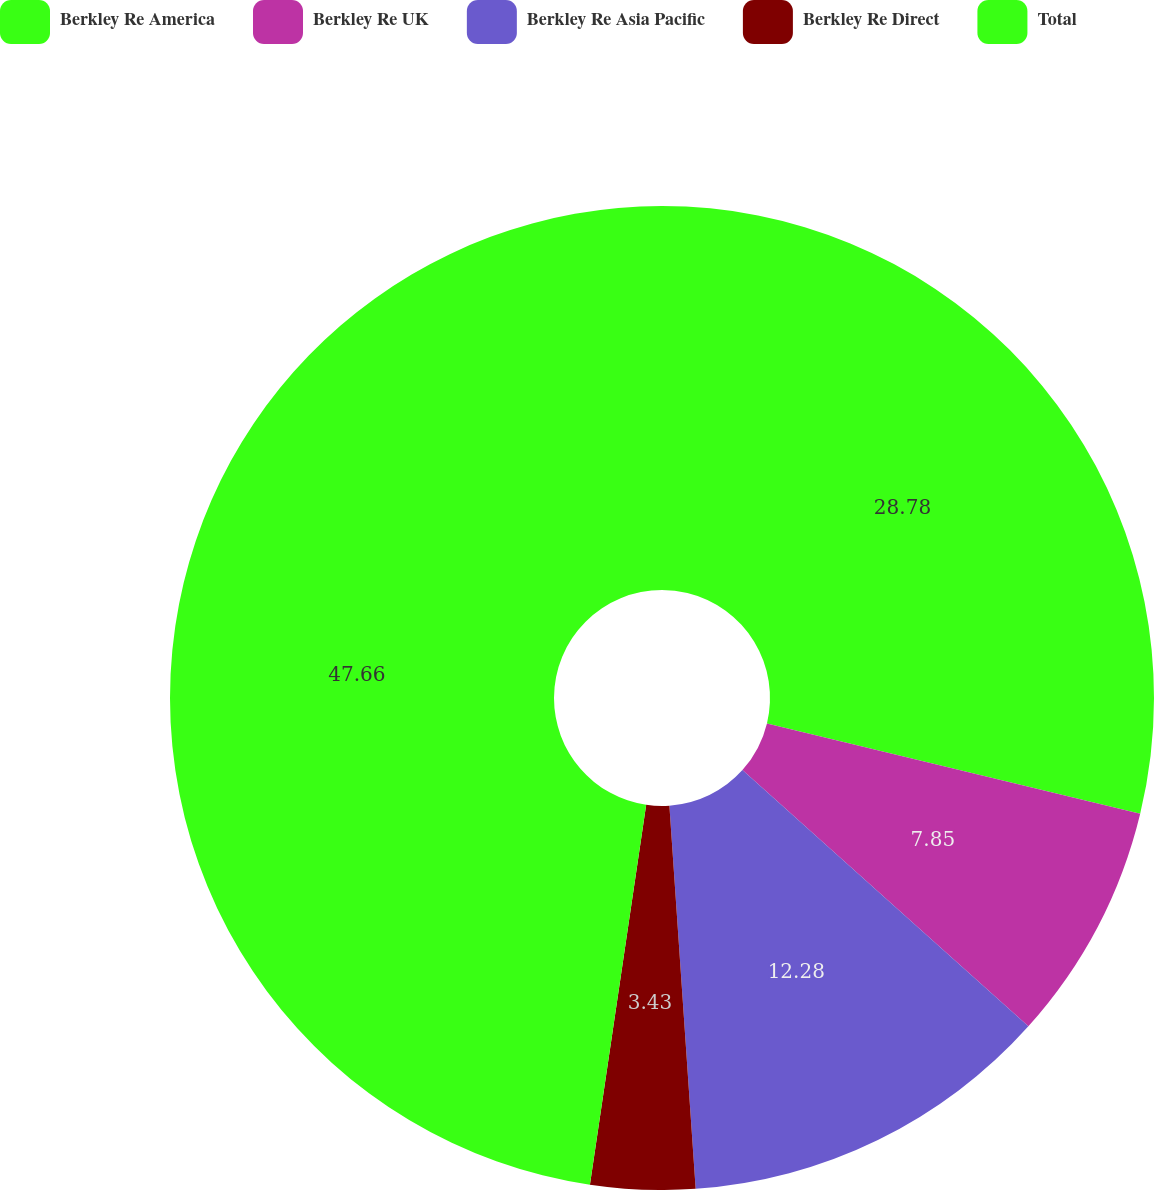<chart> <loc_0><loc_0><loc_500><loc_500><pie_chart><fcel>Berkley Re America<fcel>Berkley Re UK<fcel>Berkley Re Asia Pacific<fcel>Berkley Re Direct<fcel>Total<nl><fcel>28.78%<fcel>7.85%<fcel>12.28%<fcel>3.43%<fcel>47.66%<nl></chart> 